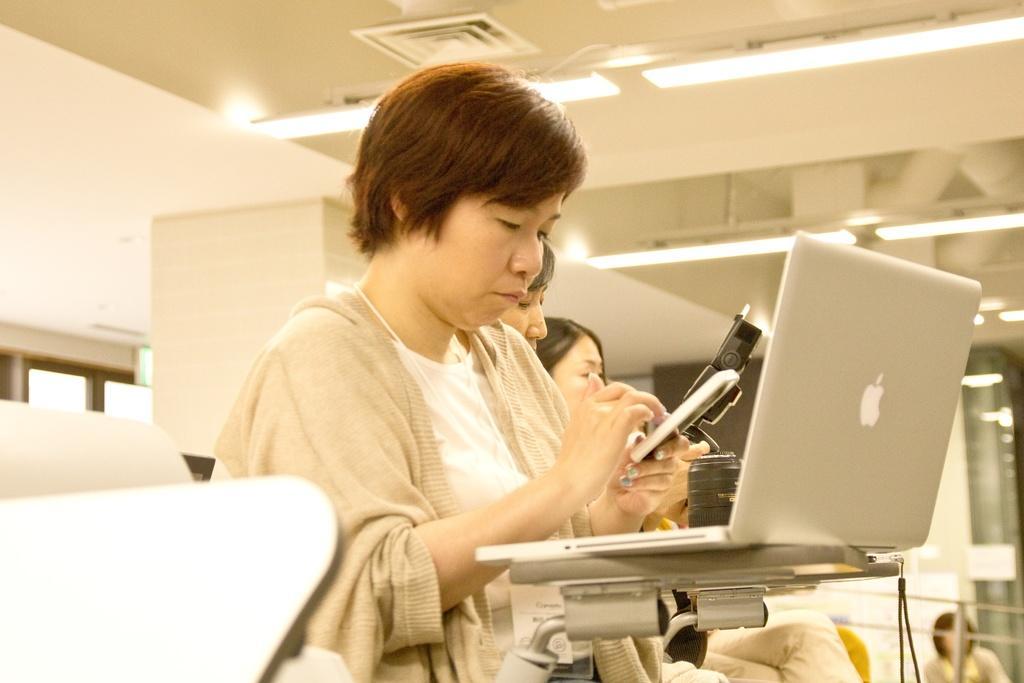Describe this image in one or two sentences. In this image there are people sitting. There is a laptop. There are chairs. There is a wall. There is roof with lights. 